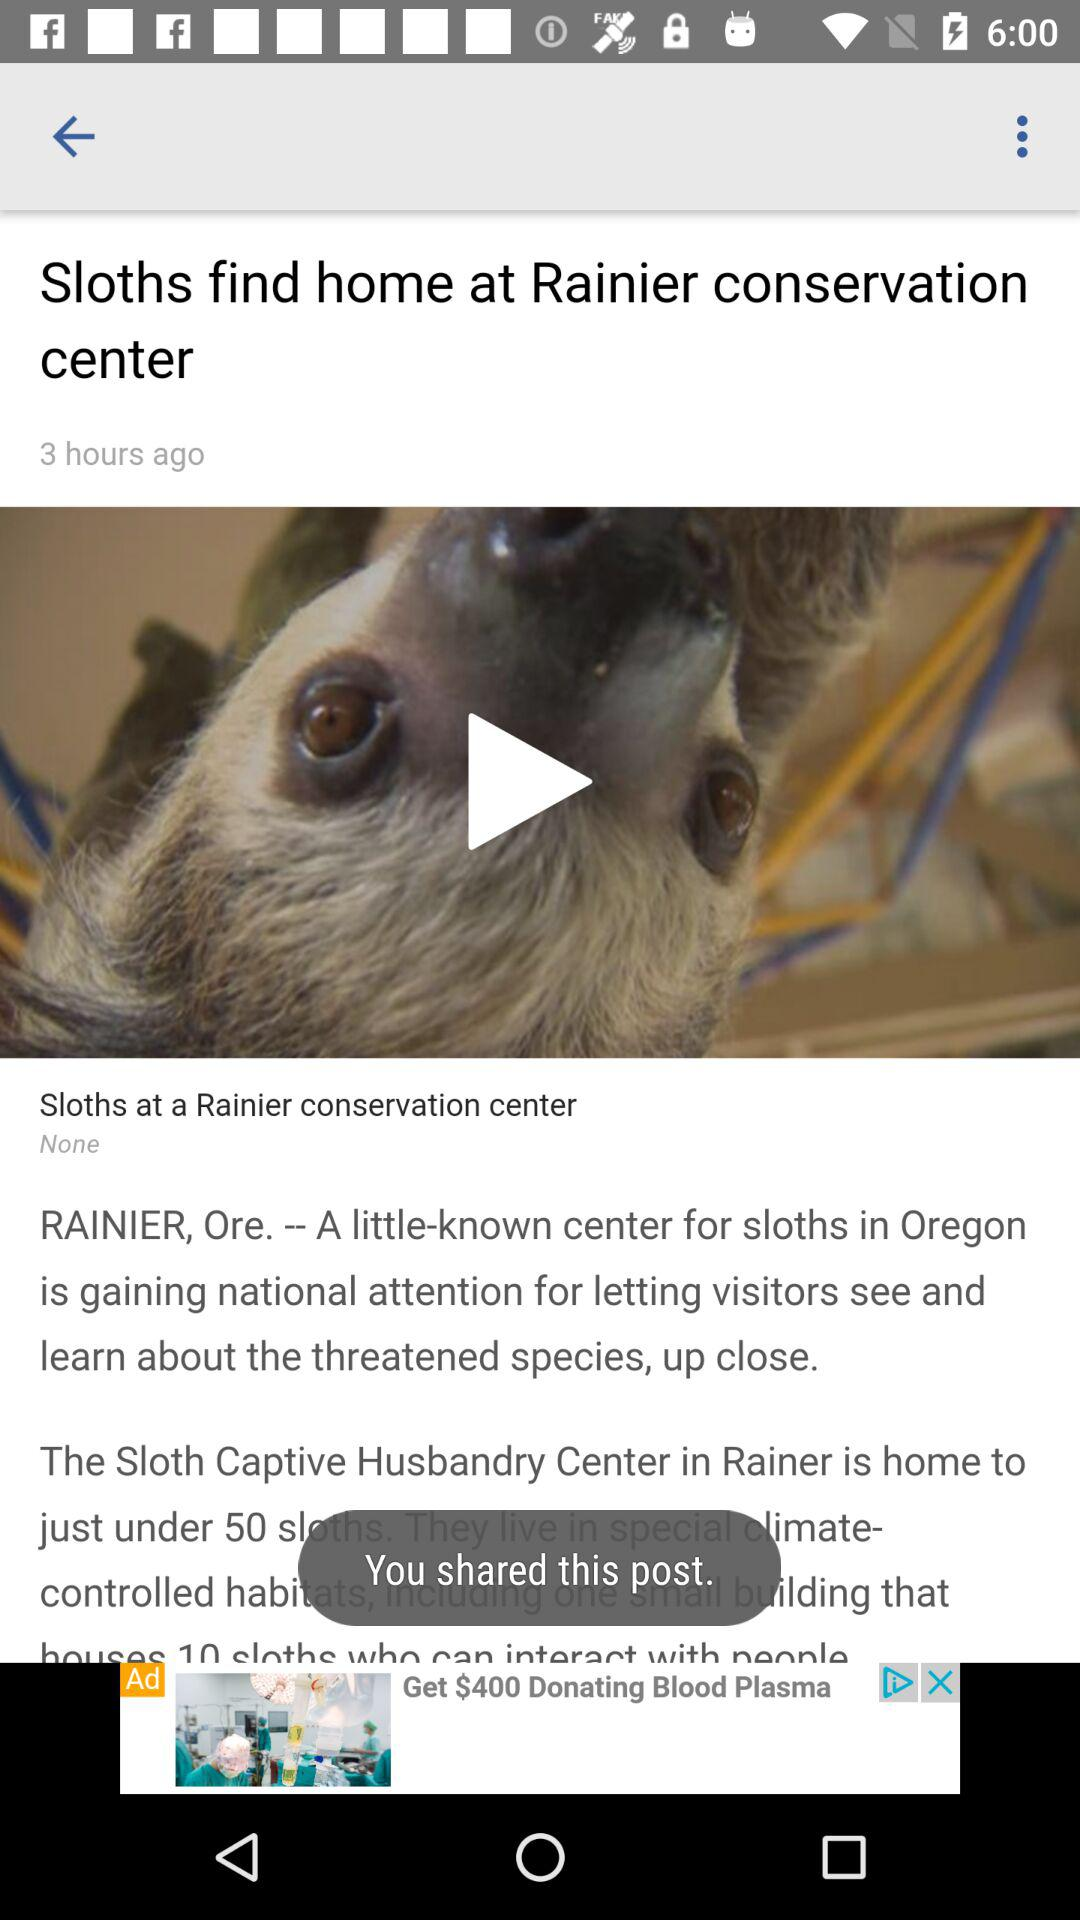At what time was the article posted? The article was posted 3 hours ago. 